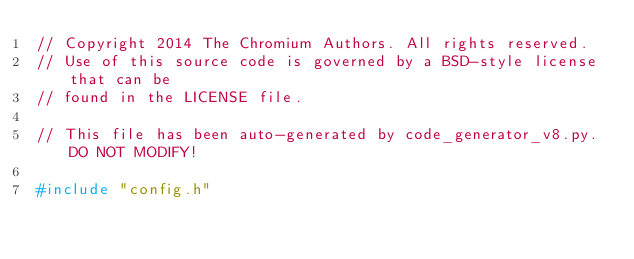<code> <loc_0><loc_0><loc_500><loc_500><_C++_>// Copyright 2014 The Chromium Authors. All rights reserved.
// Use of this source code is governed by a BSD-style license that can be
// found in the LICENSE file.

// This file has been auto-generated by code_generator_v8.py. DO NOT MODIFY!

#include "config.h"</code> 